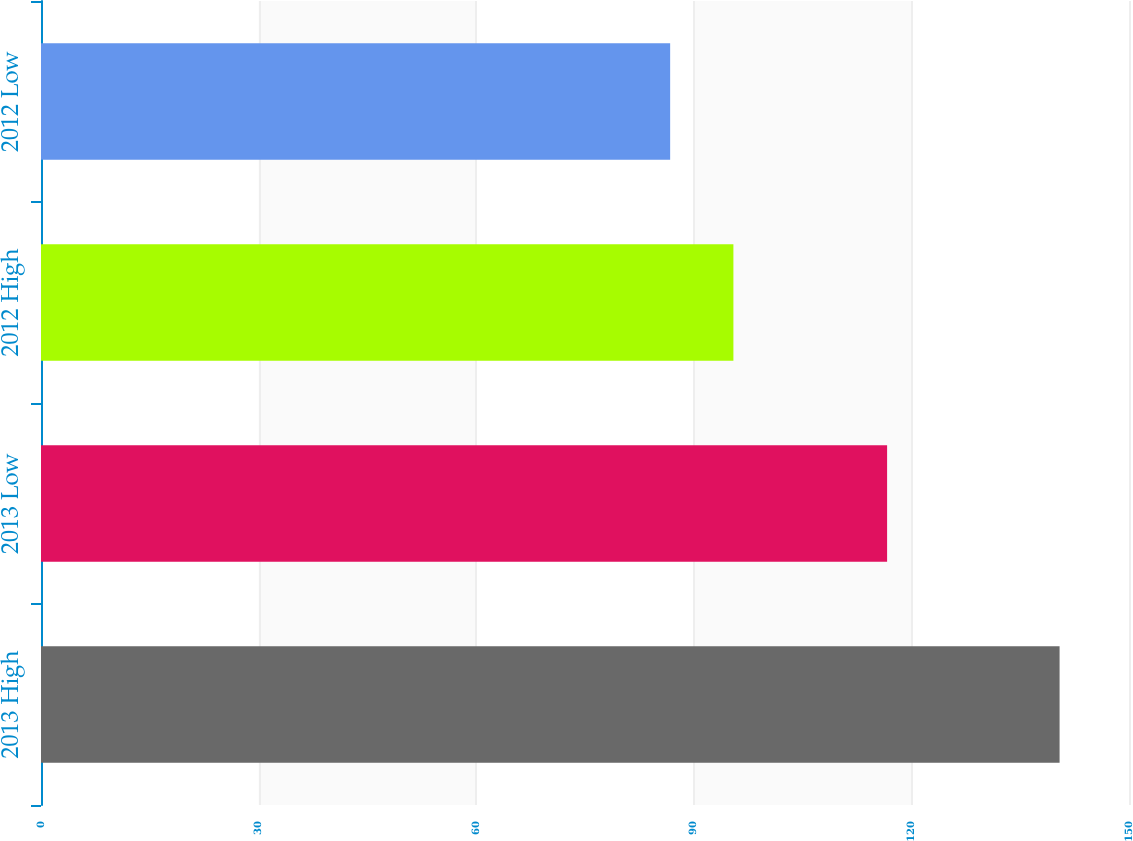Convert chart. <chart><loc_0><loc_0><loc_500><loc_500><bar_chart><fcel>2013 High<fcel>2013 Low<fcel>2012 High<fcel>2012 Low<nl><fcel>140.43<fcel>116.65<fcel>95.46<fcel>86.74<nl></chart> 